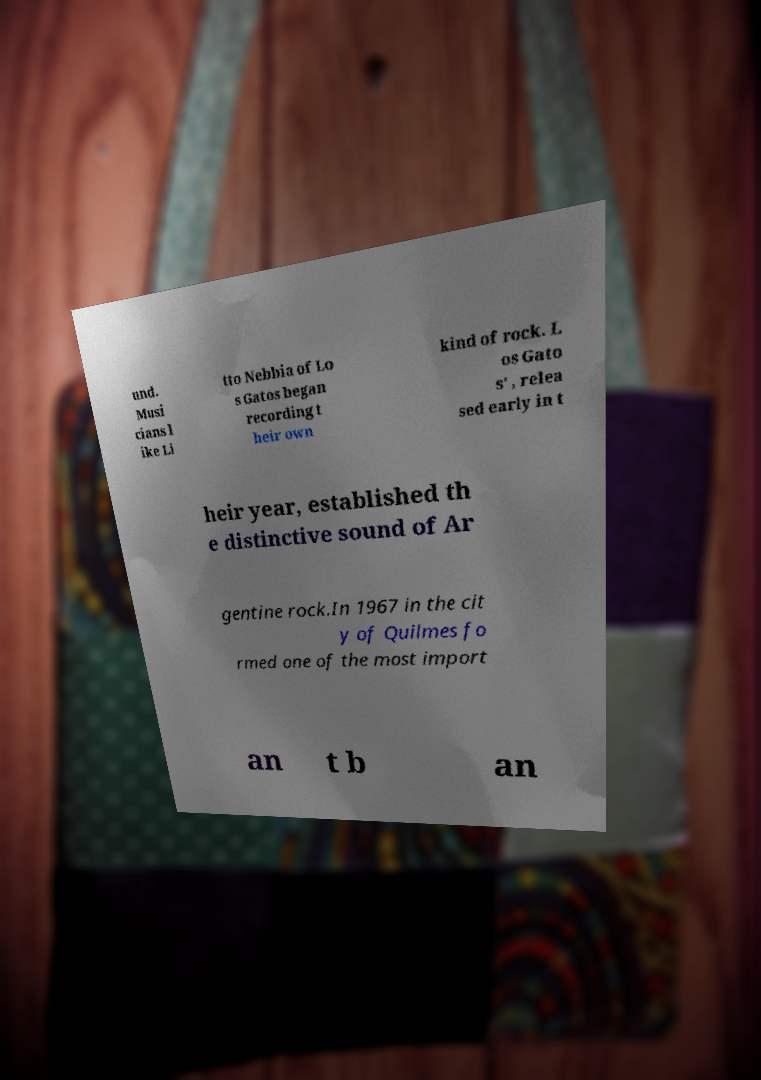I need the written content from this picture converted into text. Can you do that? und. Musi cians l ike Li tto Nebbia of Lo s Gatos began recording t heir own kind of rock. L os Gato s' , relea sed early in t heir year, established th e distinctive sound of Ar gentine rock.In 1967 in the cit y of Quilmes fo rmed one of the most import an t b an 